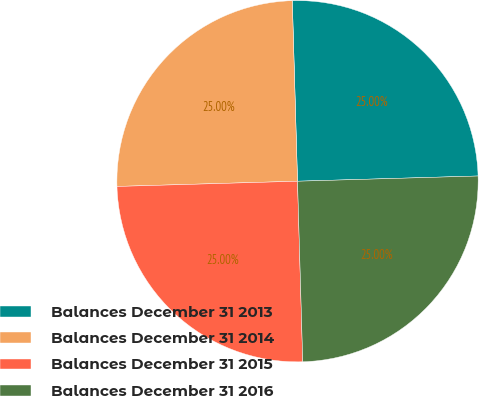Convert chart to OTSL. <chart><loc_0><loc_0><loc_500><loc_500><pie_chart><fcel>Balances December 31 2013<fcel>Balances December 31 2014<fcel>Balances December 31 2015<fcel>Balances December 31 2016<nl><fcel>25.0%<fcel>25.0%<fcel>25.0%<fcel>25.0%<nl></chart> 